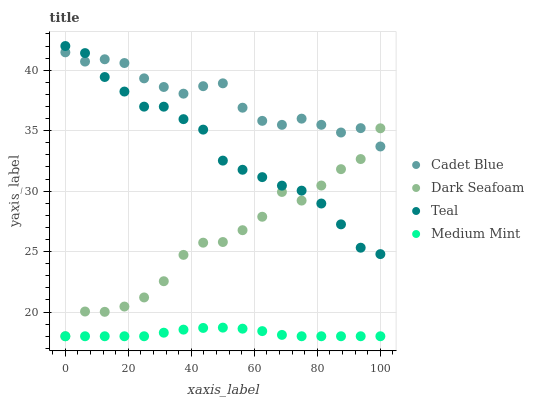Does Medium Mint have the minimum area under the curve?
Answer yes or no. Yes. Does Cadet Blue have the maximum area under the curve?
Answer yes or no. Yes. Does Dark Seafoam have the minimum area under the curve?
Answer yes or no. No. Does Dark Seafoam have the maximum area under the curve?
Answer yes or no. No. Is Medium Mint the smoothest?
Answer yes or no. Yes. Is Dark Seafoam the roughest?
Answer yes or no. Yes. Is Cadet Blue the smoothest?
Answer yes or no. No. Is Cadet Blue the roughest?
Answer yes or no. No. Does Medium Mint have the lowest value?
Answer yes or no. Yes. Does Cadet Blue have the lowest value?
Answer yes or no. No. Does Teal have the highest value?
Answer yes or no. Yes. Does Dark Seafoam have the highest value?
Answer yes or no. No. Is Medium Mint less than Cadet Blue?
Answer yes or no. Yes. Is Teal greater than Medium Mint?
Answer yes or no. Yes. Does Dark Seafoam intersect Medium Mint?
Answer yes or no. Yes. Is Dark Seafoam less than Medium Mint?
Answer yes or no. No. Is Dark Seafoam greater than Medium Mint?
Answer yes or no. No. Does Medium Mint intersect Cadet Blue?
Answer yes or no. No. 